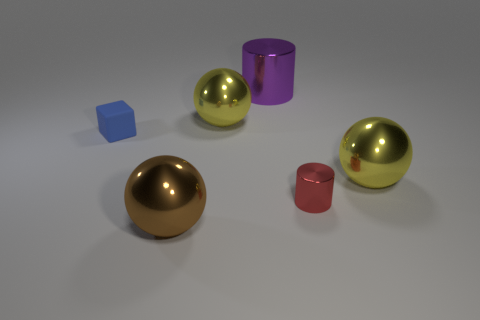Add 3 tiny blue blocks. How many objects exist? 9 Subtract all cylinders. How many objects are left? 4 Subtract all green metallic cubes. Subtract all red metallic cylinders. How many objects are left? 5 Add 2 red cylinders. How many red cylinders are left? 3 Add 2 small red cylinders. How many small red cylinders exist? 3 Subtract 1 red cylinders. How many objects are left? 5 